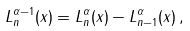<formula> <loc_0><loc_0><loc_500><loc_500>L _ { n } ^ { \alpha - 1 } ( x ) = L _ { n } ^ { \alpha } ( x ) - L _ { n - 1 } ^ { \alpha } ( x ) \, ,</formula> 